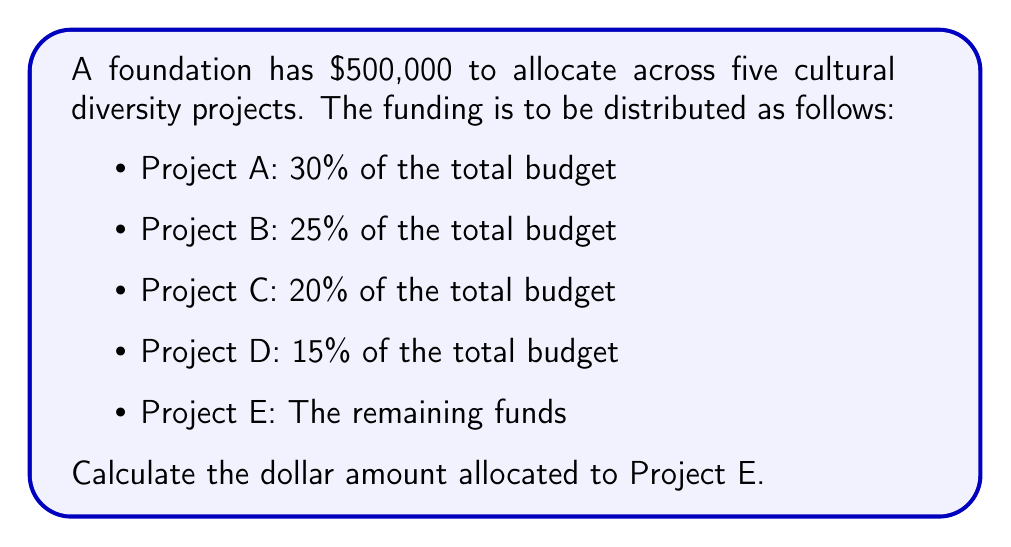Solve this math problem. To solve this problem, we'll follow these steps:

1. Calculate the amount allocated to Projects A, B, C, and D:

   Project A: $500,000 \times 30\% = $500,000 \times 0.30 = $150,000$
   Project B: $500,000 \times 25\% = $500,000 \times 0.25 = $125,000$
   Project C: $500,000 \times 20\% = $500,000 \times 0.20 = $100,000$
   Project D: $500,000 \times 15\% = $500,000 \times 0.15 = $75,000$

2. Sum up the allocations for Projects A, B, C, and D:

   $150,000 + $125,000 + $100,000 + $75,000 = $450,000$

3. Calculate the remaining funds for Project E:

   Total budget - Sum of allocations for A, B, C, and D
   $500,000 - $450,000 = $50,000$

Therefore, the amount allocated to Project E is $50,000.
Answer: $50,000 